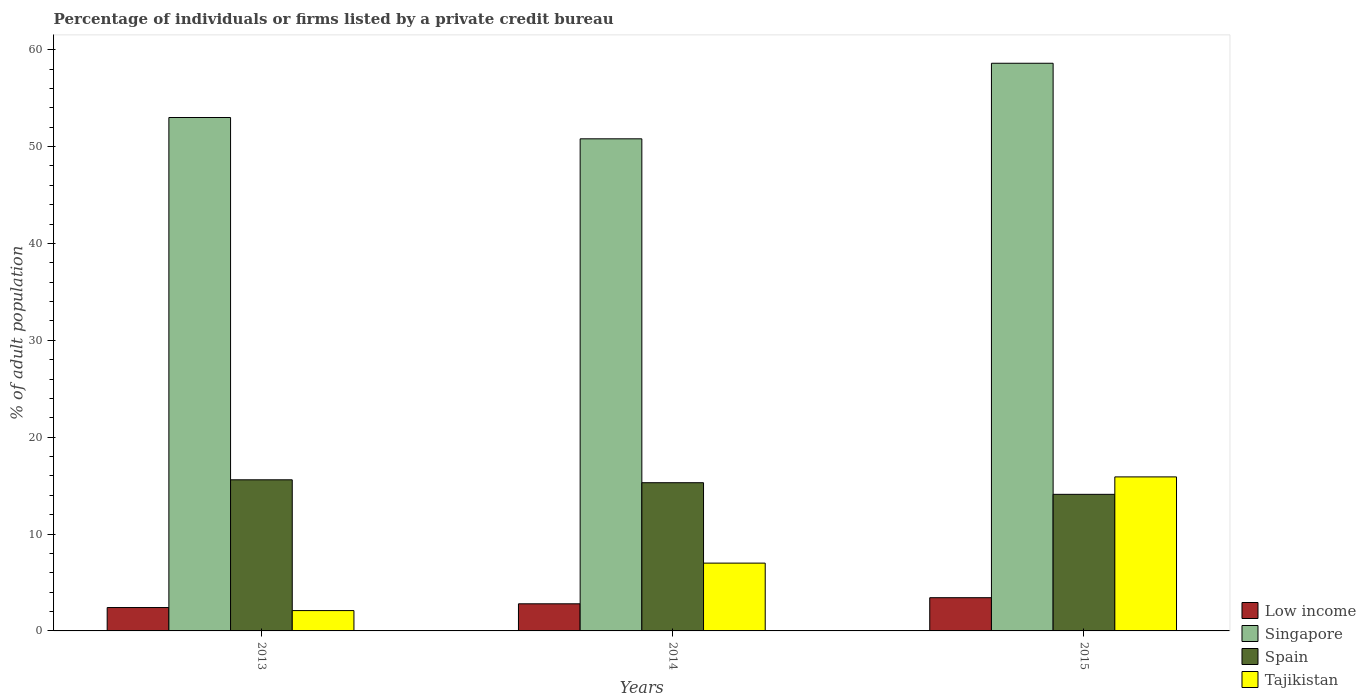How many different coloured bars are there?
Keep it short and to the point. 4. How many groups of bars are there?
Offer a terse response. 3. Are the number of bars per tick equal to the number of legend labels?
Provide a short and direct response. Yes. How many bars are there on the 2nd tick from the right?
Provide a succinct answer. 4. In how many cases, is the number of bars for a given year not equal to the number of legend labels?
Your answer should be compact. 0. Across all years, what is the maximum percentage of population listed by a private credit bureau in Singapore?
Keep it short and to the point. 58.6. Across all years, what is the minimum percentage of population listed by a private credit bureau in Singapore?
Provide a succinct answer. 50.8. In which year was the percentage of population listed by a private credit bureau in Tajikistan maximum?
Ensure brevity in your answer.  2015. In which year was the percentage of population listed by a private credit bureau in Singapore minimum?
Give a very brief answer. 2014. What is the difference between the percentage of population listed by a private credit bureau in Low income in 2014 and that in 2015?
Offer a very short reply. -0.63. What is the difference between the percentage of population listed by a private credit bureau in Tajikistan in 2015 and the percentage of population listed by a private credit bureau in Low income in 2013?
Keep it short and to the point. 13.49. In the year 2015, what is the difference between the percentage of population listed by a private credit bureau in Singapore and percentage of population listed by a private credit bureau in Low income?
Provide a short and direct response. 55.17. In how many years, is the percentage of population listed by a private credit bureau in Tajikistan greater than 6 %?
Provide a succinct answer. 2. What is the ratio of the percentage of population listed by a private credit bureau in Tajikistan in 2013 to that in 2015?
Give a very brief answer. 0.13. Is the percentage of population listed by a private credit bureau in Tajikistan in 2013 less than that in 2015?
Provide a short and direct response. Yes. What is the difference between the highest and the second highest percentage of population listed by a private credit bureau in Spain?
Offer a very short reply. 0.3. What does the 3rd bar from the right in 2014 represents?
Your answer should be very brief. Singapore. How many bars are there?
Offer a terse response. 12. Are all the bars in the graph horizontal?
Offer a very short reply. No. Are the values on the major ticks of Y-axis written in scientific E-notation?
Your answer should be very brief. No. How many legend labels are there?
Offer a terse response. 4. What is the title of the graph?
Give a very brief answer. Percentage of individuals or firms listed by a private credit bureau. Does "Italy" appear as one of the legend labels in the graph?
Your answer should be very brief. No. What is the label or title of the Y-axis?
Keep it short and to the point. % of adult population. What is the % of adult population of Low income in 2013?
Provide a short and direct response. 2.41. What is the % of adult population in Singapore in 2013?
Give a very brief answer. 53. What is the % of adult population in Spain in 2013?
Offer a very short reply. 15.6. What is the % of adult population of Tajikistan in 2013?
Your answer should be very brief. 2.1. What is the % of adult population in Low income in 2014?
Your answer should be very brief. 2.8. What is the % of adult population of Singapore in 2014?
Your answer should be compact. 50.8. What is the % of adult population in Spain in 2014?
Your answer should be very brief. 15.3. What is the % of adult population of Tajikistan in 2014?
Ensure brevity in your answer.  7. What is the % of adult population of Low income in 2015?
Your answer should be very brief. 3.43. What is the % of adult population of Singapore in 2015?
Make the answer very short. 58.6. What is the % of adult population in Spain in 2015?
Provide a succinct answer. 14.1. What is the % of adult population of Tajikistan in 2015?
Provide a short and direct response. 15.9. Across all years, what is the maximum % of adult population in Low income?
Your answer should be very brief. 3.43. Across all years, what is the maximum % of adult population in Singapore?
Your answer should be compact. 58.6. Across all years, what is the maximum % of adult population in Spain?
Provide a succinct answer. 15.6. Across all years, what is the maximum % of adult population in Tajikistan?
Offer a terse response. 15.9. Across all years, what is the minimum % of adult population of Low income?
Ensure brevity in your answer.  2.41. Across all years, what is the minimum % of adult population of Singapore?
Your response must be concise. 50.8. Across all years, what is the minimum % of adult population in Spain?
Give a very brief answer. 14.1. Across all years, what is the minimum % of adult population of Tajikistan?
Keep it short and to the point. 2.1. What is the total % of adult population of Low income in the graph?
Your answer should be compact. 8.64. What is the total % of adult population of Singapore in the graph?
Make the answer very short. 162.4. What is the difference between the % of adult population of Low income in 2013 and that in 2014?
Your answer should be compact. -0.39. What is the difference between the % of adult population in Singapore in 2013 and that in 2014?
Offer a terse response. 2.2. What is the difference between the % of adult population in Tajikistan in 2013 and that in 2014?
Provide a succinct answer. -4.9. What is the difference between the % of adult population in Low income in 2013 and that in 2015?
Offer a very short reply. -1.02. What is the difference between the % of adult population in Singapore in 2013 and that in 2015?
Your answer should be compact. -5.6. What is the difference between the % of adult population in Tajikistan in 2013 and that in 2015?
Give a very brief answer. -13.8. What is the difference between the % of adult population in Low income in 2014 and that in 2015?
Offer a very short reply. -0.63. What is the difference between the % of adult population of Tajikistan in 2014 and that in 2015?
Ensure brevity in your answer.  -8.9. What is the difference between the % of adult population of Low income in 2013 and the % of adult population of Singapore in 2014?
Offer a very short reply. -48.39. What is the difference between the % of adult population of Low income in 2013 and the % of adult population of Spain in 2014?
Ensure brevity in your answer.  -12.89. What is the difference between the % of adult population in Low income in 2013 and the % of adult population in Tajikistan in 2014?
Offer a very short reply. -4.59. What is the difference between the % of adult population in Singapore in 2013 and the % of adult population in Spain in 2014?
Provide a succinct answer. 37.7. What is the difference between the % of adult population in Singapore in 2013 and the % of adult population in Tajikistan in 2014?
Your response must be concise. 46. What is the difference between the % of adult population in Spain in 2013 and the % of adult population in Tajikistan in 2014?
Your answer should be very brief. 8.6. What is the difference between the % of adult population in Low income in 2013 and the % of adult population in Singapore in 2015?
Make the answer very short. -56.19. What is the difference between the % of adult population of Low income in 2013 and the % of adult population of Spain in 2015?
Keep it short and to the point. -11.69. What is the difference between the % of adult population in Low income in 2013 and the % of adult population in Tajikistan in 2015?
Offer a very short reply. -13.49. What is the difference between the % of adult population in Singapore in 2013 and the % of adult population in Spain in 2015?
Provide a short and direct response. 38.9. What is the difference between the % of adult population of Singapore in 2013 and the % of adult population of Tajikistan in 2015?
Give a very brief answer. 37.1. What is the difference between the % of adult population of Low income in 2014 and the % of adult population of Singapore in 2015?
Your answer should be compact. -55.8. What is the difference between the % of adult population of Low income in 2014 and the % of adult population of Spain in 2015?
Offer a very short reply. -11.3. What is the difference between the % of adult population of Low income in 2014 and the % of adult population of Tajikistan in 2015?
Keep it short and to the point. -13.1. What is the difference between the % of adult population of Singapore in 2014 and the % of adult population of Spain in 2015?
Your response must be concise. 36.7. What is the difference between the % of adult population in Singapore in 2014 and the % of adult population in Tajikistan in 2015?
Your answer should be very brief. 34.9. What is the average % of adult population in Low income per year?
Make the answer very short. 2.88. What is the average % of adult population in Singapore per year?
Provide a succinct answer. 54.13. What is the average % of adult population in Tajikistan per year?
Your answer should be very brief. 8.33. In the year 2013, what is the difference between the % of adult population of Low income and % of adult population of Singapore?
Keep it short and to the point. -50.59. In the year 2013, what is the difference between the % of adult population of Low income and % of adult population of Spain?
Keep it short and to the point. -13.19. In the year 2013, what is the difference between the % of adult population of Low income and % of adult population of Tajikistan?
Your answer should be very brief. 0.31. In the year 2013, what is the difference between the % of adult population of Singapore and % of adult population of Spain?
Provide a succinct answer. 37.4. In the year 2013, what is the difference between the % of adult population in Singapore and % of adult population in Tajikistan?
Ensure brevity in your answer.  50.9. In the year 2013, what is the difference between the % of adult population in Spain and % of adult population in Tajikistan?
Keep it short and to the point. 13.5. In the year 2014, what is the difference between the % of adult population of Low income and % of adult population of Singapore?
Keep it short and to the point. -48. In the year 2014, what is the difference between the % of adult population of Low income and % of adult population of Spain?
Offer a terse response. -12.5. In the year 2014, what is the difference between the % of adult population of Low income and % of adult population of Tajikistan?
Your response must be concise. -4.2. In the year 2014, what is the difference between the % of adult population of Singapore and % of adult population of Spain?
Offer a terse response. 35.5. In the year 2014, what is the difference between the % of adult population of Singapore and % of adult population of Tajikistan?
Keep it short and to the point. 43.8. In the year 2015, what is the difference between the % of adult population in Low income and % of adult population in Singapore?
Give a very brief answer. -55.17. In the year 2015, what is the difference between the % of adult population of Low income and % of adult population of Spain?
Your response must be concise. -10.67. In the year 2015, what is the difference between the % of adult population of Low income and % of adult population of Tajikistan?
Provide a succinct answer. -12.47. In the year 2015, what is the difference between the % of adult population in Singapore and % of adult population in Spain?
Provide a succinct answer. 44.5. In the year 2015, what is the difference between the % of adult population in Singapore and % of adult population in Tajikistan?
Provide a short and direct response. 42.7. What is the ratio of the % of adult population in Low income in 2013 to that in 2014?
Keep it short and to the point. 0.86. What is the ratio of the % of adult population of Singapore in 2013 to that in 2014?
Make the answer very short. 1.04. What is the ratio of the % of adult population of Spain in 2013 to that in 2014?
Your answer should be compact. 1.02. What is the ratio of the % of adult population in Low income in 2013 to that in 2015?
Offer a very short reply. 0.7. What is the ratio of the % of adult population of Singapore in 2013 to that in 2015?
Provide a succinct answer. 0.9. What is the ratio of the % of adult population in Spain in 2013 to that in 2015?
Offer a very short reply. 1.11. What is the ratio of the % of adult population in Tajikistan in 2013 to that in 2015?
Ensure brevity in your answer.  0.13. What is the ratio of the % of adult population in Low income in 2014 to that in 2015?
Offer a very short reply. 0.82. What is the ratio of the % of adult population in Singapore in 2014 to that in 2015?
Offer a terse response. 0.87. What is the ratio of the % of adult population of Spain in 2014 to that in 2015?
Offer a terse response. 1.09. What is the ratio of the % of adult population of Tajikistan in 2014 to that in 2015?
Offer a terse response. 0.44. What is the difference between the highest and the second highest % of adult population in Low income?
Offer a very short reply. 0.63. What is the difference between the highest and the second highest % of adult population in Singapore?
Provide a short and direct response. 5.6. What is the difference between the highest and the second highest % of adult population in Spain?
Your answer should be compact. 0.3. What is the difference between the highest and the second highest % of adult population of Tajikistan?
Your response must be concise. 8.9. What is the difference between the highest and the lowest % of adult population of Low income?
Give a very brief answer. 1.02. What is the difference between the highest and the lowest % of adult population of Singapore?
Ensure brevity in your answer.  7.8. What is the difference between the highest and the lowest % of adult population of Spain?
Offer a very short reply. 1.5. What is the difference between the highest and the lowest % of adult population of Tajikistan?
Keep it short and to the point. 13.8. 